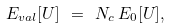Convert formula to latex. <formula><loc_0><loc_0><loc_500><loc_500>E _ { v a l } [ U ] \ = \ N _ { c } \, E _ { 0 } [ U ] ,</formula> 